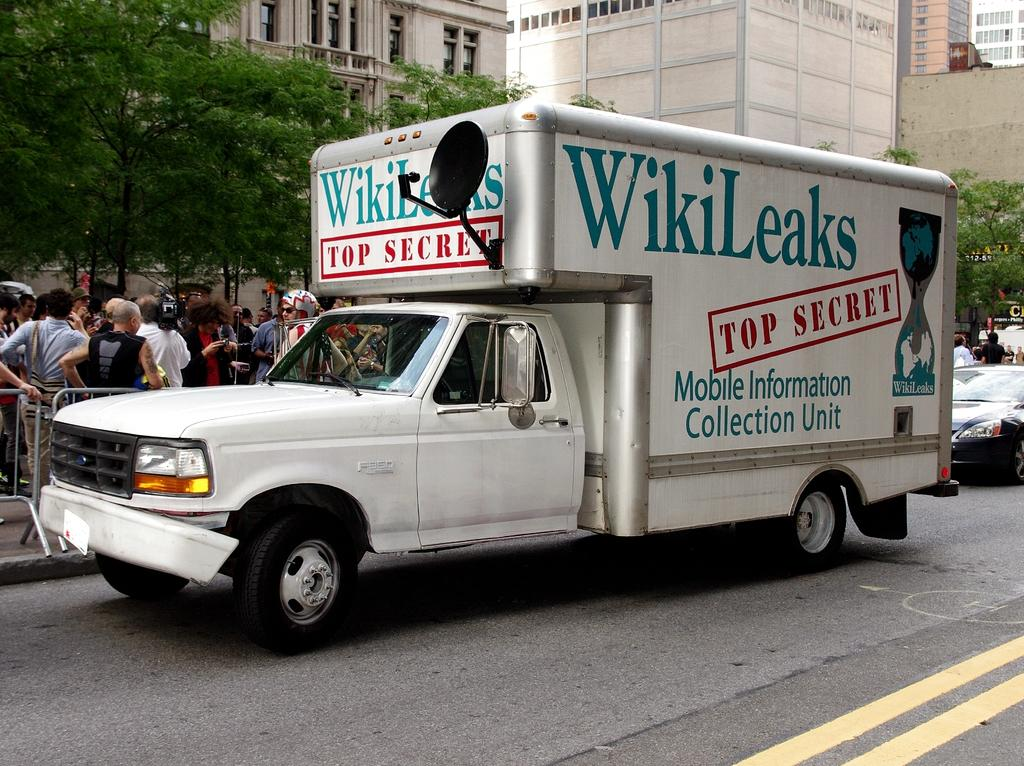What can be seen on the road in the image? There are vehicles on the road in the image. What is located near the road in the image? There is a fence in the image. Who or what is present in the image? There are people in the image. What can be seen in the distance in the image? There are buildings and trees in the background of the image. What type of spoon can be seen in the image? There is no spoon present in the image. What kind of attraction is featured in the image? There is no attraction present in the image; it features vehicles, a fence, people, buildings, and trees. 